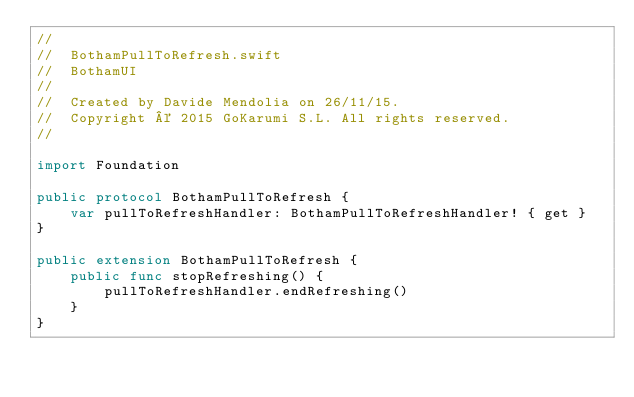<code> <loc_0><loc_0><loc_500><loc_500><_Swift_>//
//  BothamPullToRefresh.swift
//  BothamUI
//
//  Created by Davide Mendolia on 26/11/15.
//  Copyright © 2015 GoKarumi S.L. All rights reserved.
//

import Foundation

public protocol BothamPullToRefresh {
    var pullToRefreshHandler: BothamPullToRefreshHandler! { get }
}

public extension BothamPullToRefresh {
    public func stopRefreshing() {
        pullToRefreshHandler.endRefreshing()
    }
}</code> 